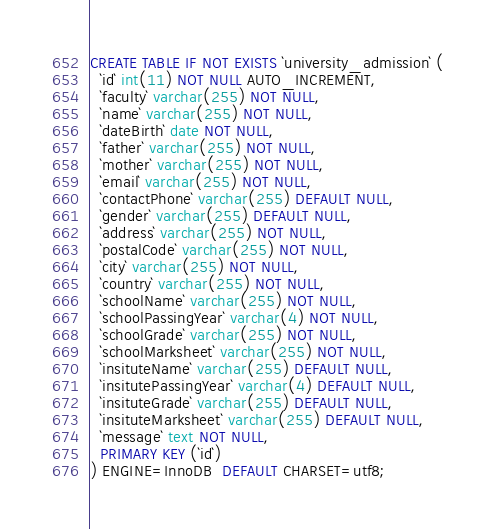Convert code to text. <code><loc_0><loc_0><loc_500><loc_500><_SQL_>CREATE TABLE IF NOT EXISTS `university_admission` (
  `id` int(11) NOT NULL AUTO_INCREMENT,
  `faculty` varchar(255) NOT NULL,
  `name` varchar(255) NOT NULL,
  `dateBirth` date NOT NULL,
  `father` varchar(255) NOT NULL,
  `mother` varchar(255) NOT NULL,
  `email` varchar(255) NOT NULL,
  `contactPhone` varchar(255) DEFAULT NULL,
  `gender` varchar(255) DEFAULT NULL,
  `address` varchar(255) NOT NULL,
  `postalCode` varchar(255) NOT NULL,
  `city` varchar(255) NOT NULL,
  `country` varchar(255) NOT NULL,
  `schoolName` varchar(255) NOT NULL,
  `schoolPassingYear` varchar(4) NOT NULL,
  `schoolGrade` varchar(255) NOT NULL,
  `schoolMarksheet` varchar(255) NOT NULL,
  `insituteName` varchar(255) DEFAULT NULL,
  `insitutePassingYear` varchar(4) DEFAULT NULL,
  `insituteGrade` varchar(255) DEFAULT NULL,
  `insituteMarksheet` varchar(255) DEFAULT NULL,
  `message` text NOT NULL,
  PRIMARY KEY (`id`)
) ENGINE=InnoDB  DEFAULT CHARSET=utf8;</code> 